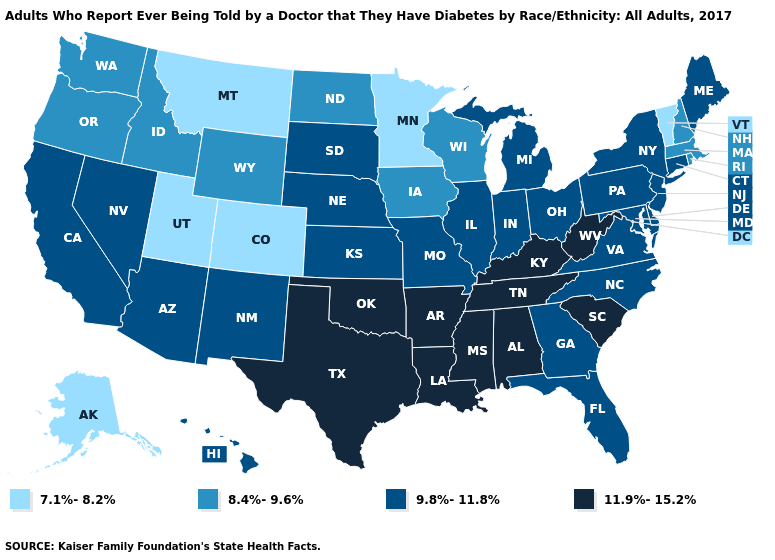Which states have the lowest value in the USA?
Give a very brief answer. Alaska, Colorado, Minnesota, Montana, Utah, Vermont. Name the states that have a value in the range 7.1%-8.2%?
Write a very short answer. Alaska, Colorado, Minnesota, Montana, Utah, Vermont. What is the highest value in the USA?
Quick response, please. 11.9%-15.2%. What is the lowest value in states that border Arizona?
Concise answer only. 7.1%-8.2%. What is the value of Missouri?
Write a very short answer. 9.8%-11.8%. What is the value of New York?
Be succinct. 9.8%-11.8%. What is the value of Kentucky?
Write a very short answer. 11.9%-15.2%. Which states have the highest value in the USA?
Keep it brief. Alabama, Arkansas, Kentucky, Louisiana, Mississippi, Oklahoma, South Carolina, Tennessee, Texas, West Virginia. Is the legend a continuous bar?
Short answer required. No. Among the states that border Wisconsin , does Illinois have the highest value?
Concise answer only. Yes. Does Alabama have the highest value in the USA?
Write a very short answer. Yes. What is the lowest value in states that border Tennessee?
Give a very brief answer. 9.8%-11.8%. Name the states that have a value in the range 9.8%-11.8%?
Keep it brief. Arizona, California, Connecticut, Delaware, Florida, Georgia, Hawaii, Illinois, Indiana, Kansas, Maine, Maryland, Michigan, Missouri, Nebraska, Nevada, New Jersey, New Mexico, New York, North Carolina, Ohio, Pennsylvania, South Dakota, Virginia. Does Kansas have the lowest value in the MidWest?
Concise answer only. No. What is the lowest value in the South?
Be succinct. 9.8%-11.8%. 